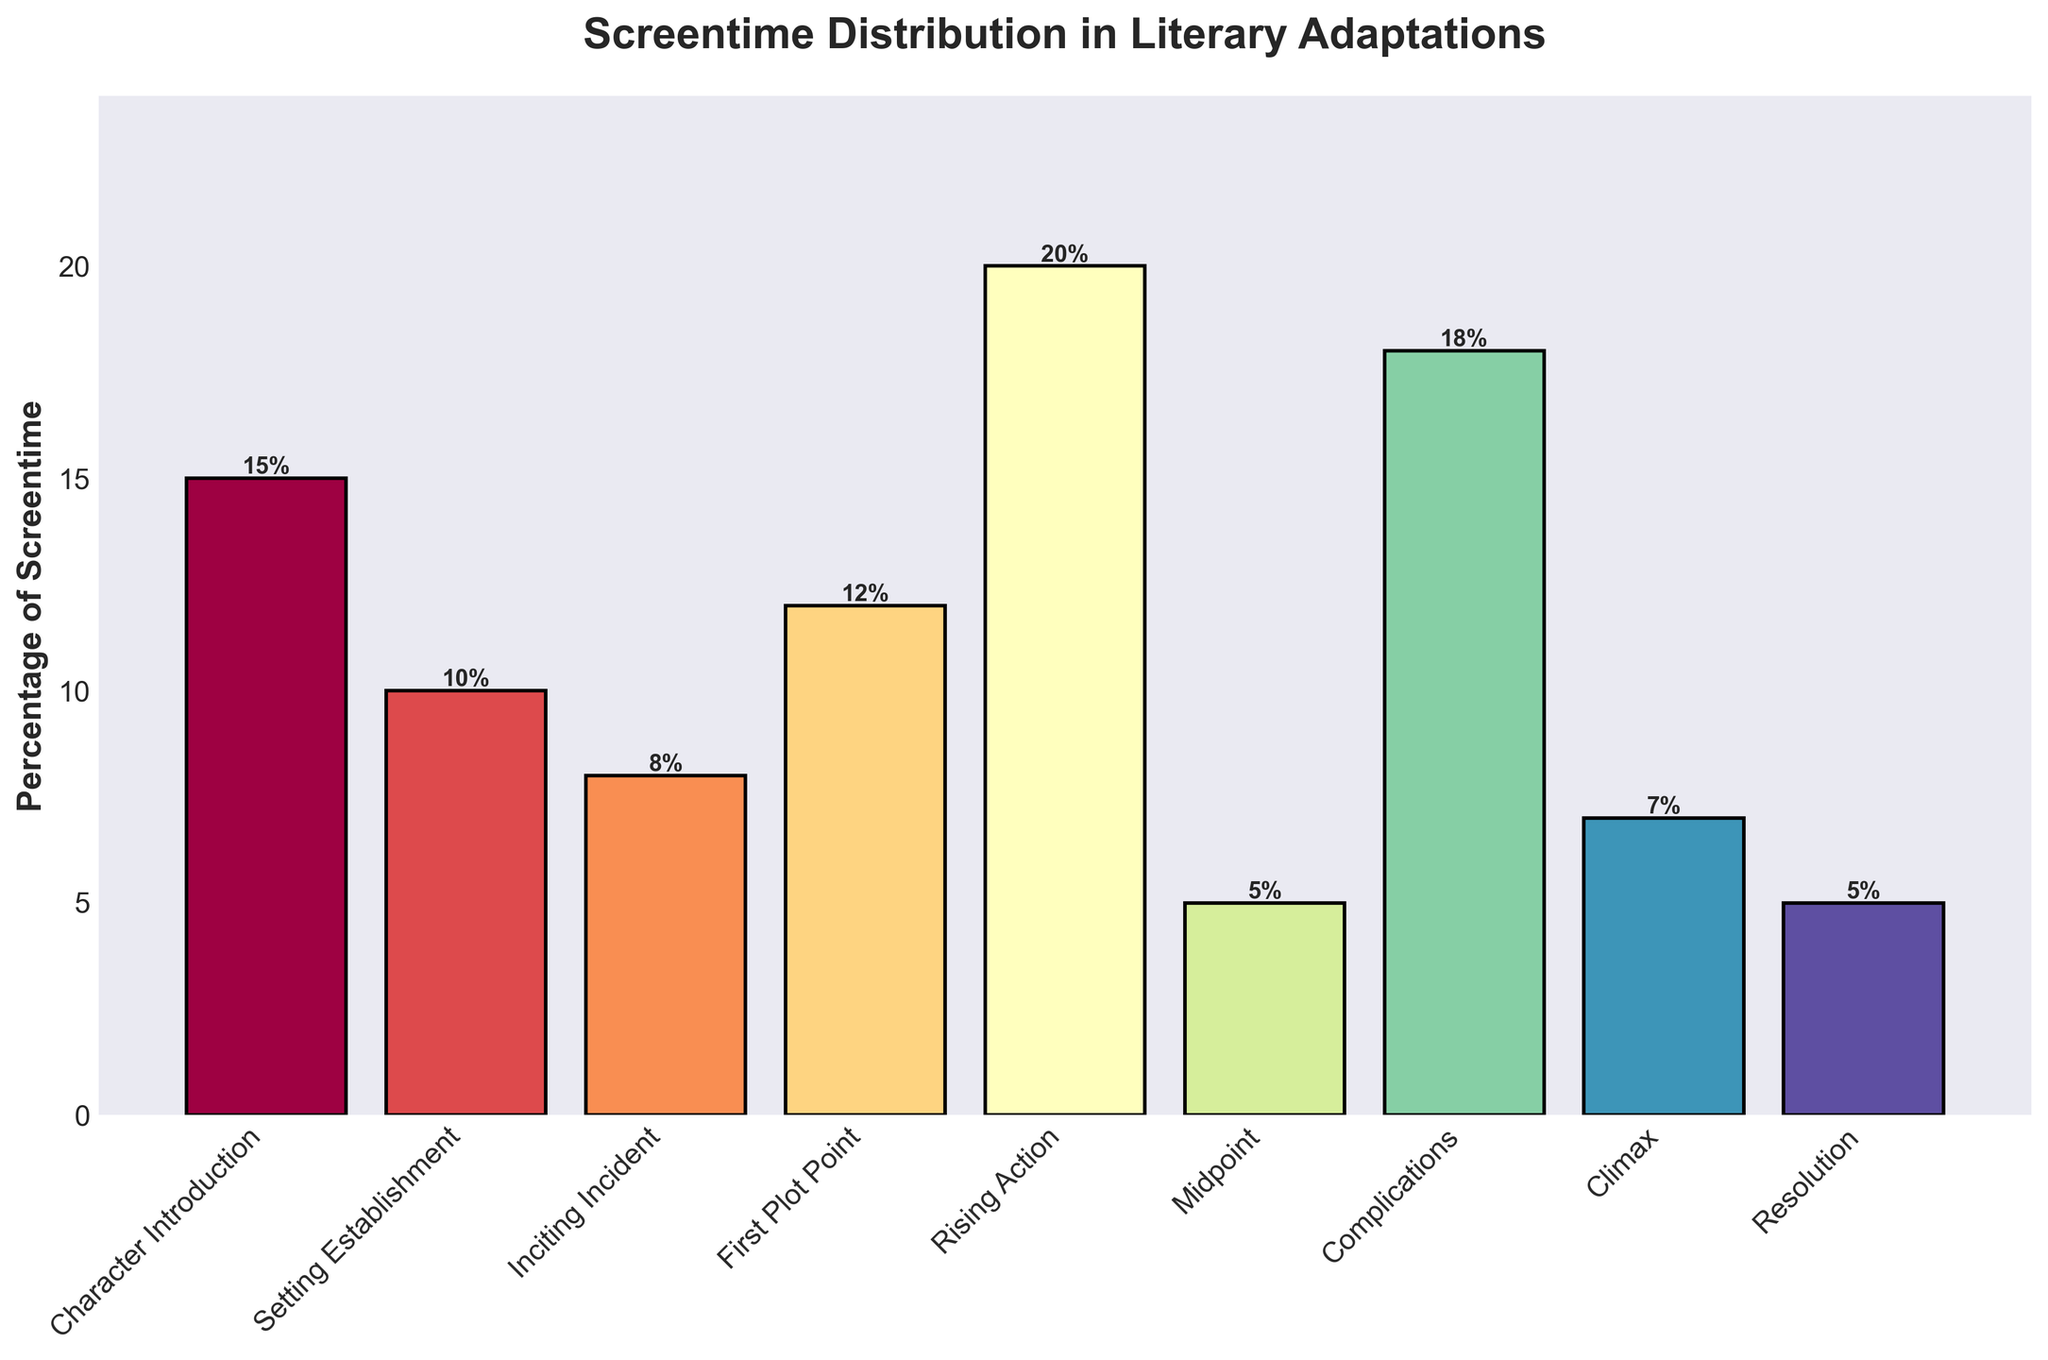What percentage of screentime is devoted to the climax? The bar representing the climax shows a height of 7%, as indicated by the label above the bar.
Answer: 7% Which plot point has the highest percentage of screentime? The bar for "Rising Action" is the tallest one in the chart, indicating it has the highest percentage, and its label shows 20%.
Answer: Rising Action How much more screentime is given to setting establishment compared to the midpoint? The percentage for "Setting Establishment" is 10% and "Midpoint" is 5%. The difference is 10% - 5% = 5%.
Answer: 5% Are there any plot points with an equal percentage of screentime? If so, which ones? Both the "Midpoint" and "Resolution" have bars that are labeled with 5%, showing an equal percentage.
Answer: Midpoint and Resolution What is the total percentage of screentime devoted to the first plot point and complications combined? The percentages are 12% for the "First Plot Point" and 18% for "Complications". Summing these gives 12% + 18% = 30%.
Answer: 30% Which has a greater percentage of screentime: the inciting incident or the climax? The bar for "Inciting Incident" is labeled with 8% and the bar for "Climax" with 7%. Therefore, the "Inciting Incident" has the greater percentage.
Answer: Inciting Incident What percentage of screentime is covered by character introduction and resolution together? The percentages are 15% for "Character Introduction" and 5% for "Resolution". Summing these gives 15% + 5% = 20%.
Answer: 20% What is the difference in screentime between the first plot point and the rising action? The "First Plot Point" has 12% and the "Rising Action" has 20%. The difference is 20% - 12% = 8%.
Answer: 8% Arrange the plot points in ascending order of their screentime percentage. Listing the percentages for each plot point and sorting them gives: Midpoint (5%), Resolution (5%), Climax (7%), Inciting Incident (8%), Setting Establishment (10%), First Plot Point (12%), Complications (18%), and Rising Action (20%).
Answer: Midpoint, Resolution, Climax, Inciting Incident, Setting Establishment, First Plot Point, Complications, Rising Action What is the average percentage of screentime for all plot points combined? Summing all the percentages (15% + 10% + 8% + 12% + 20% + 5% + 18% + 7% + 5%) gives 100%. There are 9 plot points, so the average is 100% / 9 ≈ 11.11%.
Answer: 11.11% 